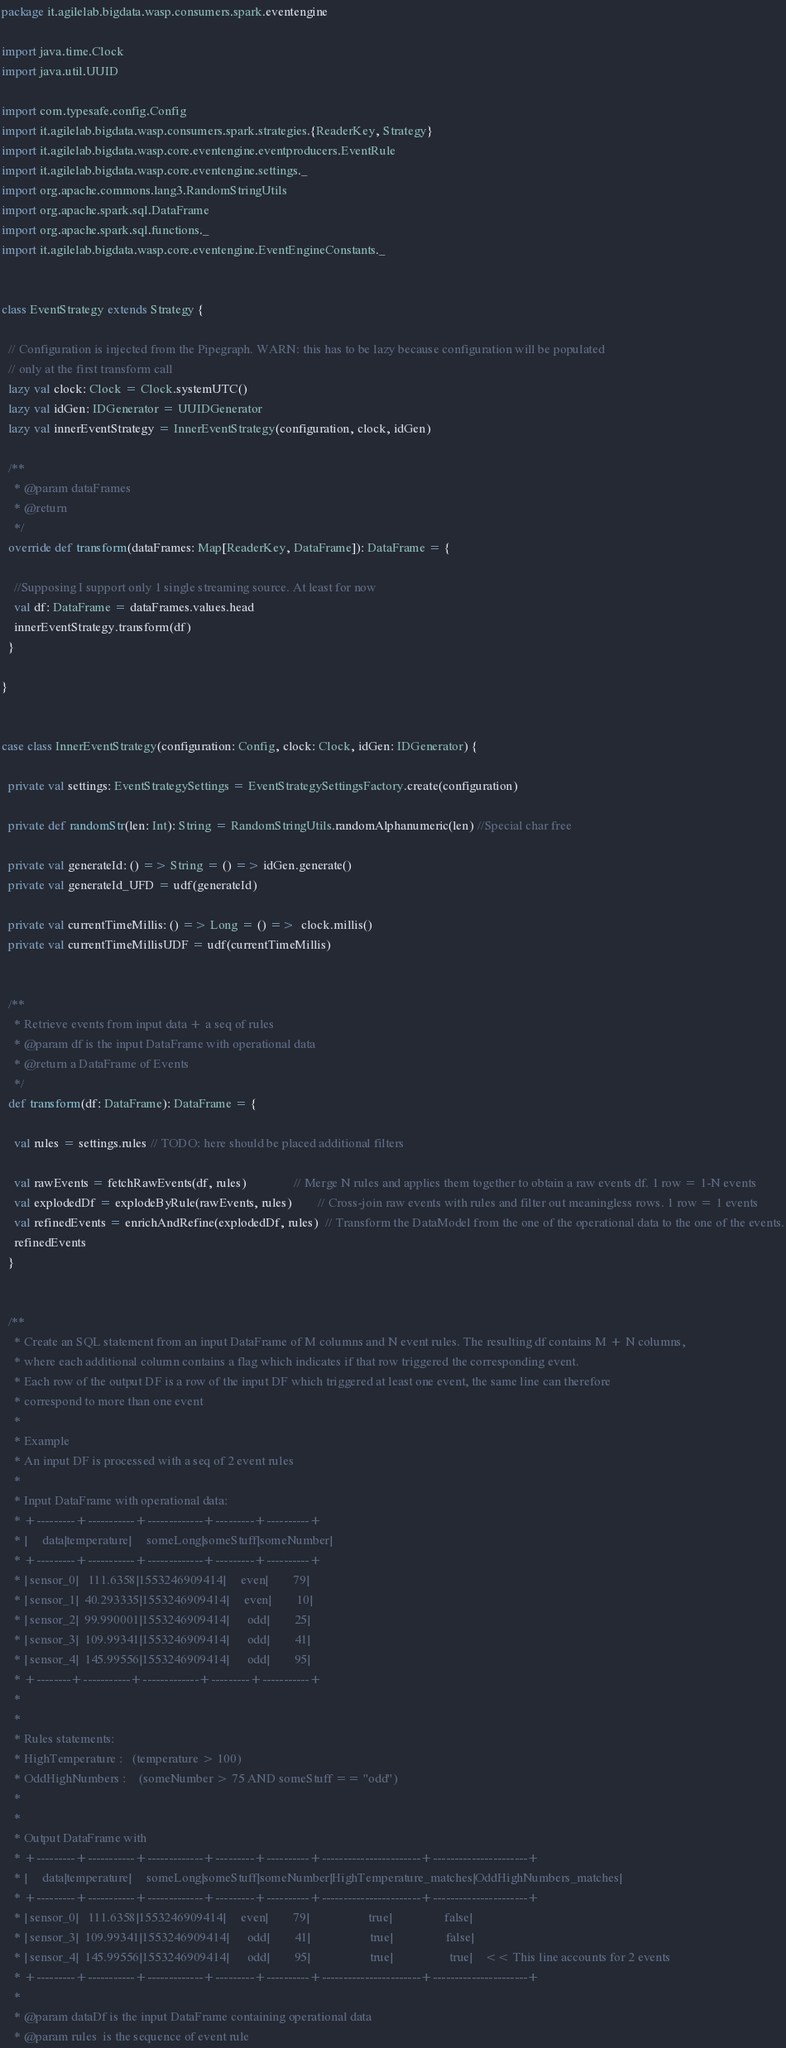Convert code to text. <code><loc_0><loc_0><loc_500><loc_500><_Scala_>package it.agilelab.bigdata.wasp.consumers.spark.eventengine

import java.time.Clock
import java.util.UUID

import com.typesafe.config.Config
import it.agilelab.bigdata.wasp.consumers.spark.strategies.{ReaderKey, Strategy}
import it.agilelab.bigdata.wasp.core.eventengine.eventproducers.EventRule
import it.agilelab.bigdata.wasp.core.eventengine.settings._
import org.apache.commons.lang3.RandomStringUtils
import org.apache.spark.sql.DataFrame
import org.apache.spark.sql.functions._
import it.agilelab.bigdata.wasp.core.eventengine.EventEngineConstants._


class EventStrategy extends Strategy {

  // Configuration is injected from the Pipegraph. WARN: this has to be lazy because configuration will be populated
  // only at the first transform call
  lazy val clock: Clock = Clock.systemUTC()
  lazy val idGen: IDGenerator = UUIDGenerator
  lazy val innerEventStrategy = InnerEventStrategy(configuration, clock, idGen)

  /**
    * @param dataFrames
    * @return
    */
  override def transform(dataFrames: Map[ReaderKey, DataFrame]): DataFrame = {

    //Supposing I support only 1 single streaming source. At least for now
    val df: DataFrame = dataFrames.values.head
    innerEventStrategy.transform(df)
  }

}


case class InnerEventStrategy(configuration: Config, clock: Clock, idGen: IDGenerator) {

  private val settings: EventStrategySettings = EventStrategySettingsFactory.create(configuration)

  private def randomStr(len: Int): String = RandomStringUtils.randomAlphanumeric(len) //Special char free

  private val generateId: () => String = () => idGen.generate()
  private val generateId_UFD = udf(generateId)

  private val currentTimeMillis: () => Long = () =>  clock.millis()
  private val currentTimeMillisUDF = udf(currentTimeMillis)


  /**
    * Retrieve events from input data + a seq of rules
    * @param df is the input DataFrame with operational data
    * @return a DataFrame of Events
    */
  def transform(df: DataFrame): DataFrame = {

    val rules = settings.rules // TODO: here should be placed additional filters

    val rawEvents = fetchRawEvents(df, rules)               // Merge N rules and applies them together to obtain a raw events df. 1 row = 1-N events
    val explodedDf = explodeByRule(rawEvents, rules)        // Cross-join raw events with rules and filter out meaningless rows. 1 row = 1 events
    val refinedEvents = enrichAndRefine(explodedDf, rules)  // Transform the DataModel from the one of the operational data to the one of the events.
    refinedEvents
  }


  /**
    * Create an SQL statement from an input DataFrame of M columns and N event rules. The resulting df contains M + N columns,
    * where each additional column contains a flag which indicates if that row triggered the corresponding event.
    * Each row of the output DF is a row of the input DF which triggered at least one event, the same line can therefore
    * correspond to more than one event
    *
    * Example
    * An input DF is processed with a seq of 2 event rules
    *
    * Input DataFrame with operational data:
    * +---------+-----------+-------------+---------+----------+
    * |     data|temperature|     someLong|someStuff|someNumber|
    * +---------+-----------+-------------+---------+----------+
    * | sensor_0|   111.6358|1553246909414|     even|        79|
    * | sensor_1|  40.293335|1553246909414|     even|        10|
    * | sensor_2|  99.990001|1553246909414|      odd|        25|
    * | sensor_3|  109.99341|1553246909414|      odd|        41|
    * | sensor_4|  145.99556|1553246909414|      odd|        95|
    * +--------+-----------+-------------+---------+-----------+
    *
    *
    * Rules statements:
    * HighTemperature :   (temperature > 100)
    * OddHighNumbers :    (someNumber > 75 AND someStuff == "odd")
    *
    *
    * Output DataFrame with
    * +---------+-----------+-------------+---------+----------+-----------------------+----------------------+
    * |     data|temperature|     someLong|someStuff|someNumber|HighTemperature_matches|OddHighNumbers_matches|
    * +---------+-----------+-------------+---------+----------+-----------------------+----------------------+
    * | sensor_0|   111.6358|1553246909414|     even|        79|                   true|                 false|
    * | sensor_3|  109.99341|1553246909414|      odd|        41|                   true|                 false|
    * | sensor_4|  145.99556|1553246909414|      odd|        95|                   true|                  true|    << This line accounts for 2 events
    * +---------+-----------+-------------+---------+----------+-----------------------+----------------------+
    *
    * @param dataDf is the input DataFrame containing operational data
    * @param rules  is the sequence of event rule</code> 